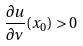Convert formula to latex. <formula><loc_0><loc_0><loc_500><loc_500>\frac { \partial u } { \partial \nu } ( x _ { 0 } ) > 0</formula> 